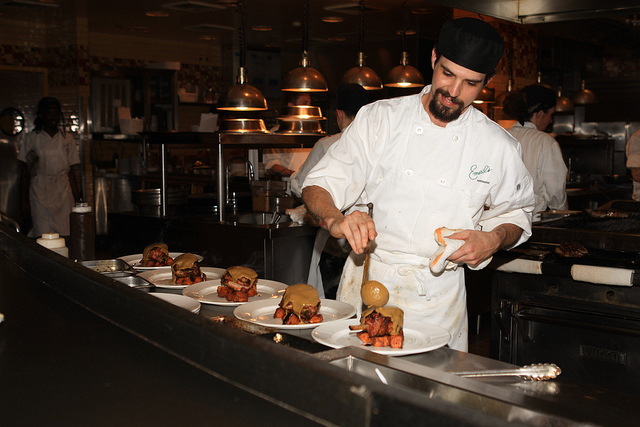<image>What is this man preparing with the ladle? It is unknown what the man is preparing with the ladle. It could be gravy, soup, or sauce. What is this man preparing with the ladle? I don't know what the man is preparing with the ladle. It can be food, diner, gravy, soup, or sauces. 